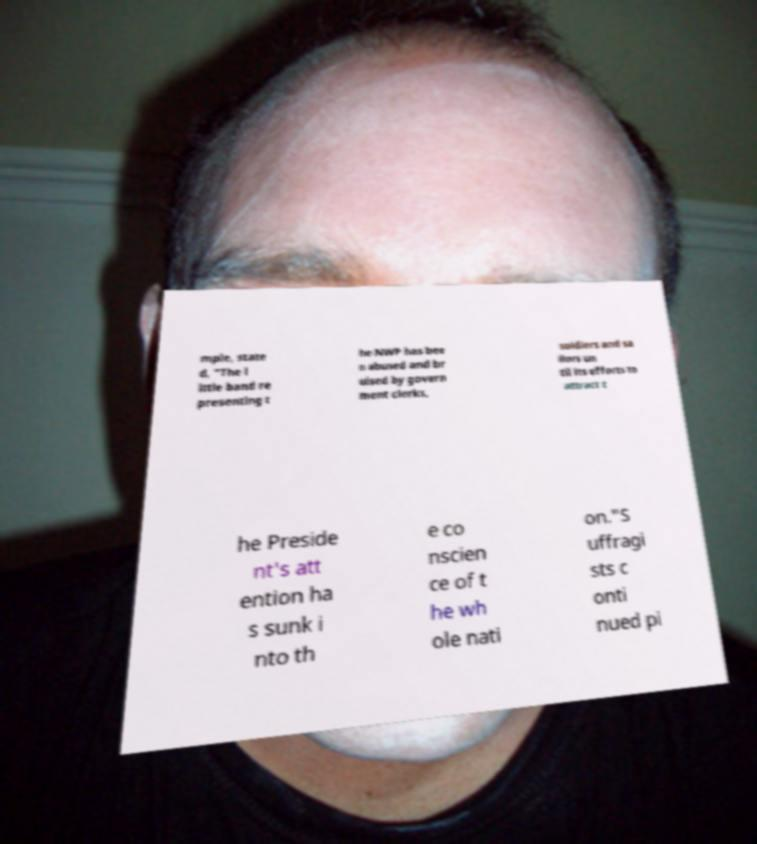I need the written content from this picture converted into text. Can you do that? mple, state d, "The l ittle band re presenting t he NWP has bee n abused and br uised by govern ment clerks, soldiers and sa ilors un til its efforts to attract t he Preside nt's att ention ha s sunk i nto th e co nscien ce of t he wh ole nati on."S uffragi sts c onti nued pi 